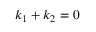Convert formula to latex. <formula><loc_0><loc_0><loc_500><loc_500>k _ { 1 } + k _ { 2 } = 0</formula> 